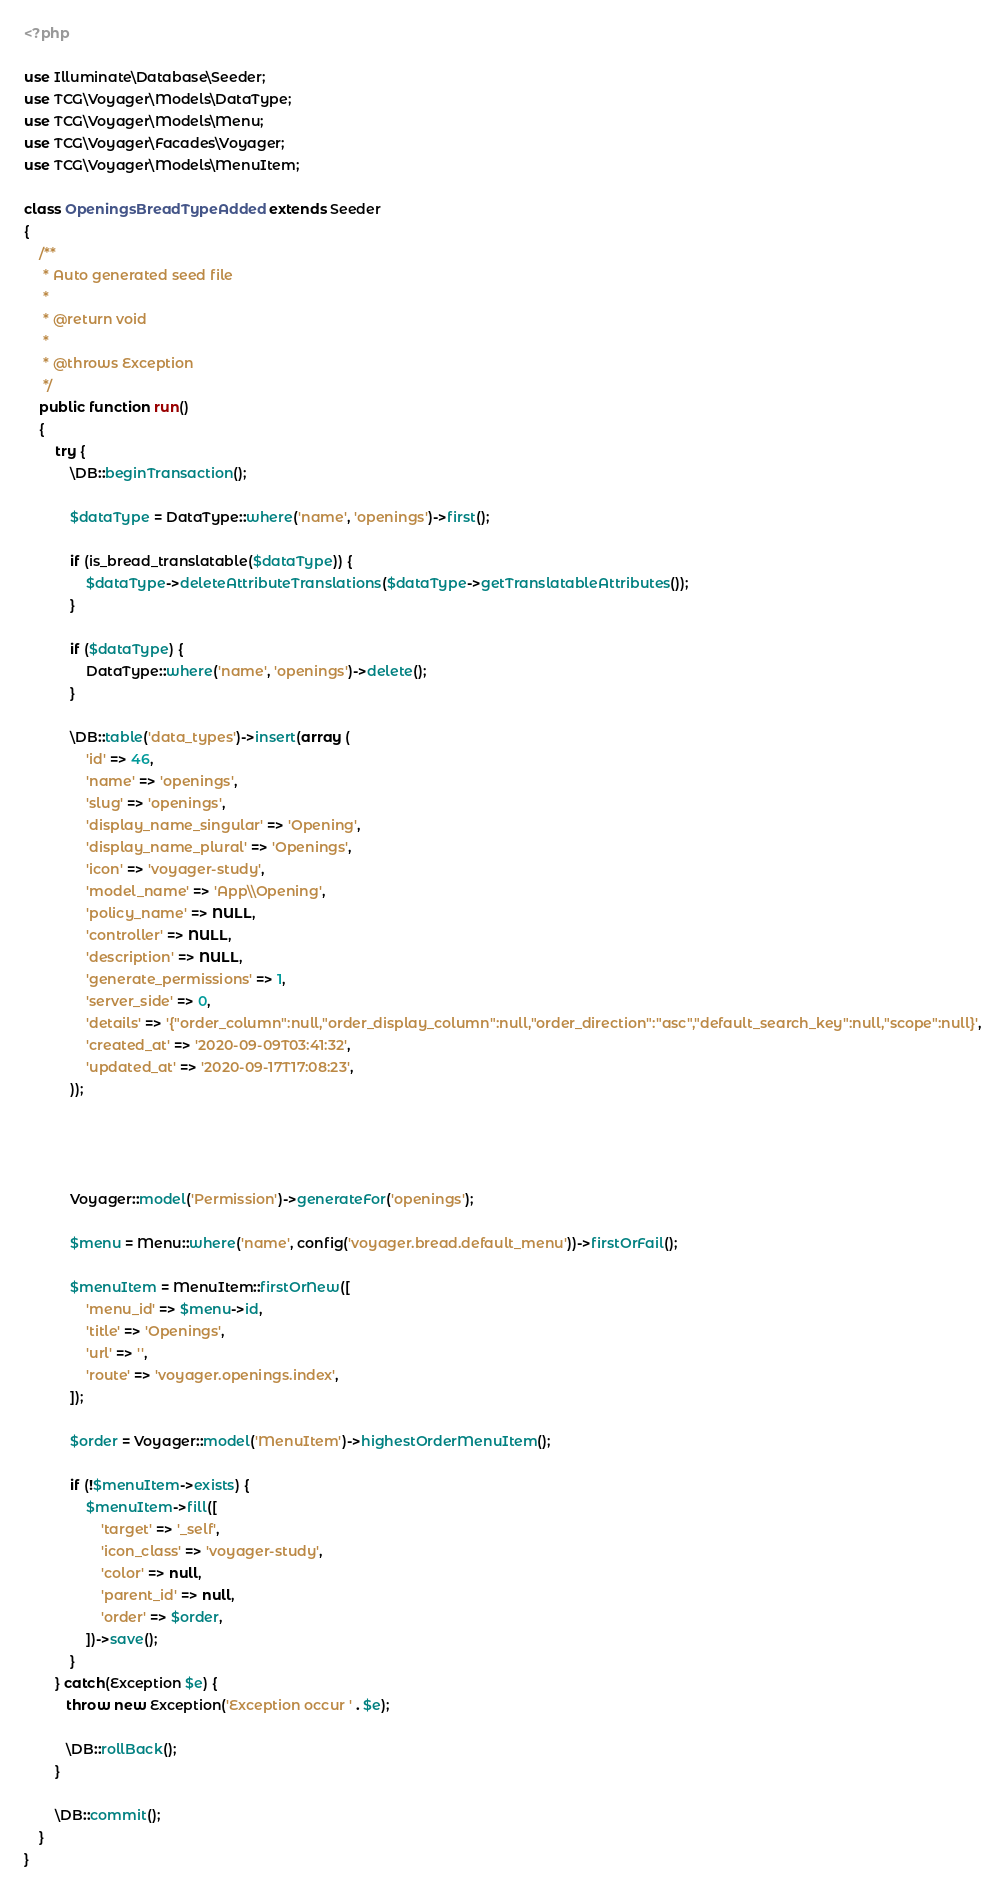Convert code to text. <code><loc_0><loc_0><loc_500><loc_500><_PHP_><?php

use Illuminate\Database\Seeder;
use TCG\Voyager\Models\DataType;
use TCG\Voyager\Models\Menu;
use TCG\Voyager\Facades\Voyager;
use TCG\Voyager\Models\MenuItem;

class OpeningsBreadTypeAdded extends Seeder
{
    /**
     * Auto generated seed file
     *
     * @return void
     *
     * @throws Exception
     */
    public function run()
    {
        try {
            \DB::beginTransaction();

            $dataType = DataType::where('name', 'openings')->first();

            if (is_bread_translatable($dataType)) {
                $dataType->deleteAttributeTranslations($dataType->getTranslatableAttributes());
            }

            if ($dataType) {
                DataType::where('name', 'openings')->delete();
            }

            \DB::table('data_types')->insert(array (
                'id' => 46,
                'name' => 'openings',
                'slug' => 'openings',
                'display_name_singular' => 'Opening',
                'display_name_plural' => 'Openings',
                'icon' => 'voyager-study',
                'model_name' => 'App\\Opening',
                'policy_name' => NULL,
                'controller' => NULL,
                'description' => NULL,
                'generate_permissions' => 1,
                'server_side' => 0,
                'details' => '{"order_column":null,"order_display_column":null,"order_direction":"asc","default_search_key":null,"scope":null}',
                'created_at' => '2020-09-09T03:41:32',
                'updated_at' => '2020-09-17T17:08:23',
            ));

            
            

            Voyager::model('Permission')->generateFor('openings');

            $menu = Menu::where('name', config('voyager.bread.default_menu'))->firstOrFail();

            $menuItem = MenuItem::firstOrNew([
                'menu_id' => $menu->id,
                'title' => 'Openings',
                'url' => '',
                'route' => 'voyager.openings.index',
            ]);

            $order = Voyager::model('MenuItem')->highestOrderMenuItem();

            if (!$menuItem->exists) {
                $menuItem->fill([
                    'target' => '_self',
                    'icon_class' => 'voyager-study',
                    'color' => null,
                    'parent_id' => null,
                    'order' => $order,
                ])->save();
            }
        } catch(Exception $e) {
           throw new Exception('Exception occur ' . $e);

           \DB::rollBack();
        }

        \DB::commit();
    }
}
</code> 